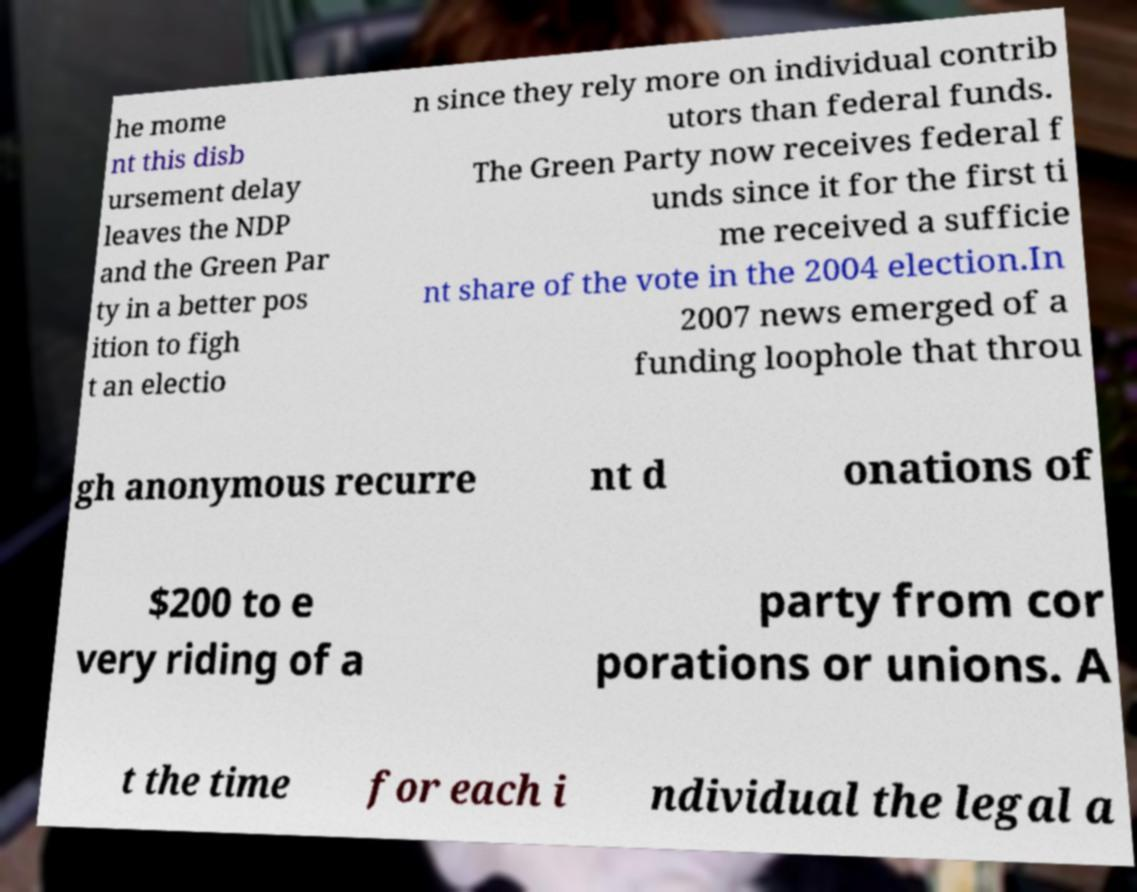Can you read and provide the text displayed in the image?This photo seems to have some interesting text. Can you extract and type it out for me? he mome nt this disb ursement delay leaves the NDP and the Green Par ty in a better pos ition to figh t an electio n since they rely more on individual contrib utors than federal funds. The Green Party now receives federal f unds since it for the first ti me received a sufficie nt share of the vote in the 2004 election.In 2007 news emerged of a funding loophole that throu gh anonymous recurre nt d onations of $200 to e very riding of a party from cor porations or unions. A t the time for each i ndividual the legal a 